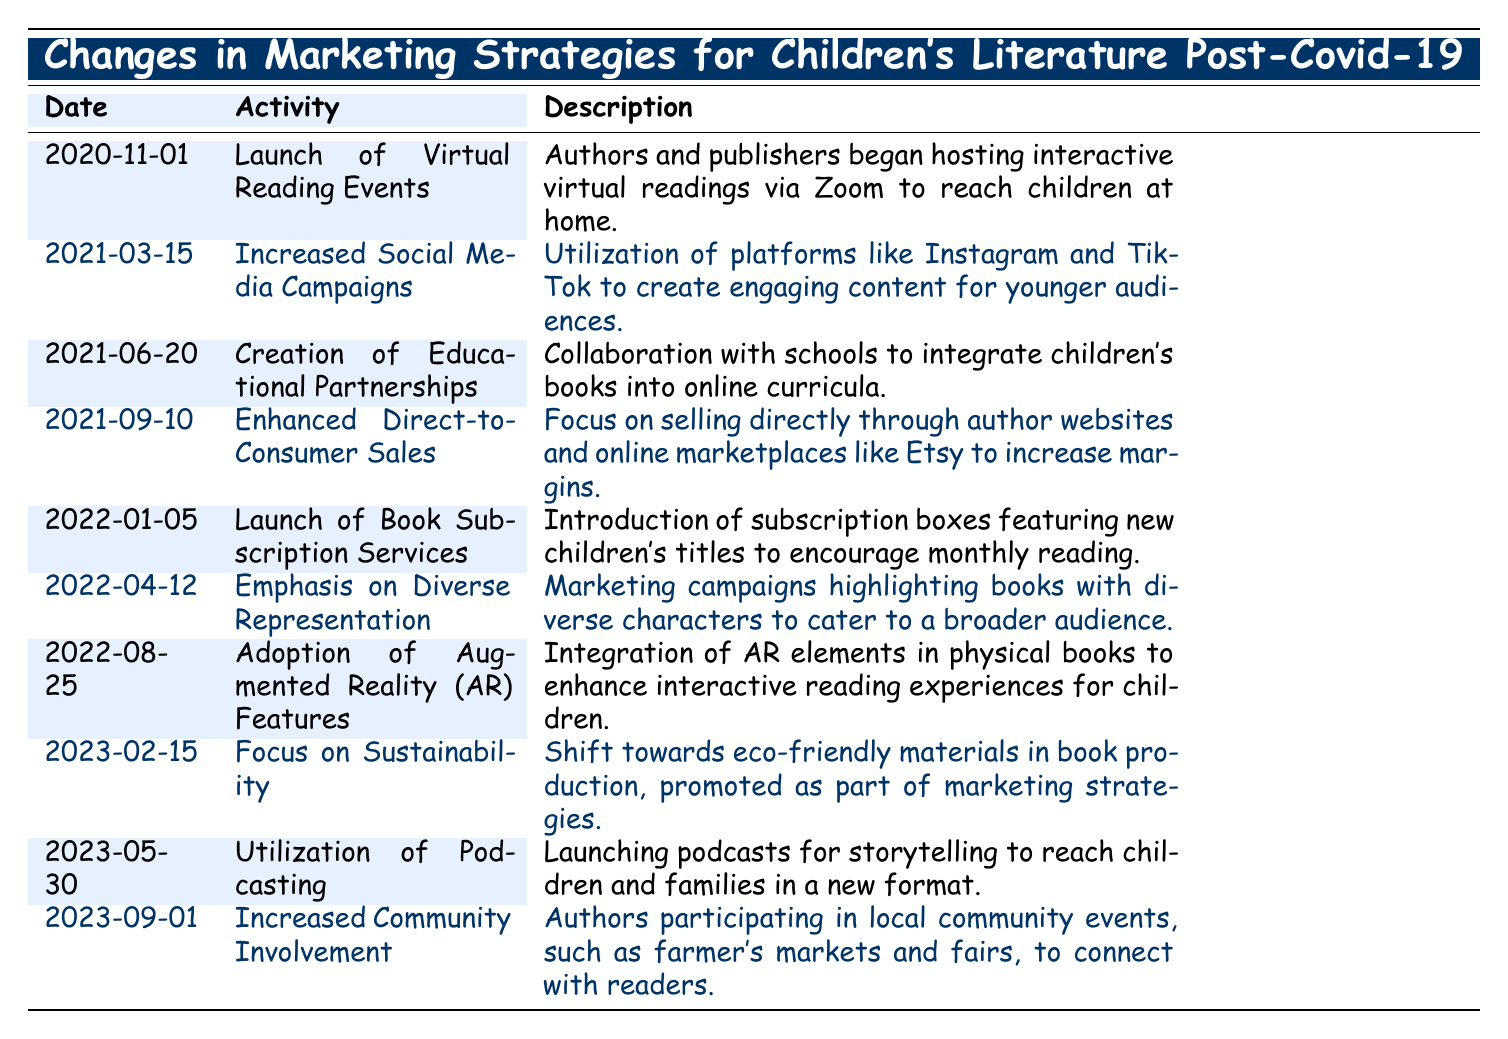What activity was launched on November 1, 2020? Referring to the table, the activity listed for that date is "Launch of Virtual Reading Events."
Answer: Launch of Virtual Reading Events What was emphasized in marketing on April 12, 2022? The table indicates that the activity on this date was "Emphasis on Diverse Representation."
Answer: Emphasis on Diverse Representation How many activities were launched in 2022? By examining the table, we find activities listed for January, April, and August in 2022—totaling three activities.
Answer: Three activities Was there a focus on sustainability in children's literature marketing in 2023? The table shows a specific entry titled "Focus on Sustainability," confirming that sustainability was indeed a focus.
Answer: Yes Which marketing strategy was most recent in the table? The most recent date listed in the table is September 1, 2023, which includes the activity "Increased Community Involvement."
Answer: Increased Community Involvement What is the average time gap between the activities in 2021? Listing the dates, we see events on March 15, June 20, and September 10. The gaps between March and June is about 3 months, and between June and September is about 3 months again. Therefore, the average gap is (3+3) / 2 = 3 months.
Answer: 3 months How many of the activities mentioned involve direct interaction with readers? From the table, both "Launch of Virtual Reading Events" and "Increased Community Involvement" facilitate direct interaction, totaling two activities.
Answer: Two activities Was there any activity that combined technology with children's literature? The table lists "Adoption of Augmented Reality (AR) Features," which indeed combines technology with children’s literature, answering the question positively.
Answer: Yes What was the primary goal of the book subscription services launched on January 5, 2022? The table describes this activity as aimed at encouraging monthly reading through subscription boxes featuring new children's titles.
Answer: Encourage monthly reading 